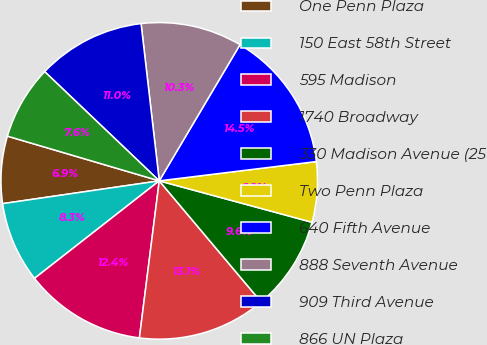<chart> <loc_0><loc_0><loc_500><loc_500><pie_chart><fcel>One Penn Plaza<fcel>150 East 58th Street<fcel>595 Madison<fcel>1740 Broadway<fcel>330 Madison Avenue (25<fcel>Two Penn Plaza<fcel>640 Fifth Avenue<fcel>888 Seventh Avenue<fcel>909 Third Avenue<fcel>866 UN Plaza<nl><fcel>6.86%<fcel>8.26%<fcel>12.44%<fcel>13.14%<fcel>9.65%<fcel>6.16%<fcel>14.54%<fcel>10.35%<fcel>11.05%<fcel>7.56%<nl></chart> 